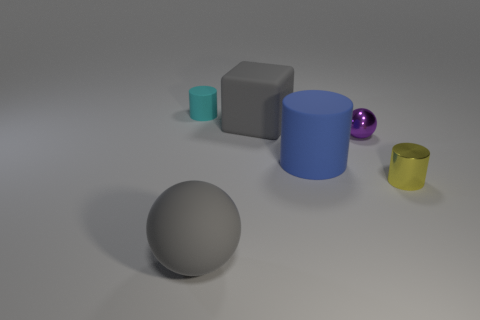What color is the ball that is the same material as the yellow object?
Make the answer very short. Purple. How many metal things are either tiny yellow things or large cubes?
Provide a short and direct response. 1. Is the material of the tiny purple object the same as the large sphere?
Keep it short and to the point. No. There is a rubber thing in front of the yellow cylinder; what shape is it?
Offer a very short reply. Sphere. Are there any matte cylinders that are on the right side of the ball that is in front of the yellow cylinder?
Keep it short and to the point. Yes. Are there any purple shiny spheres that have the same size as the yellow object?
Ensure brevity in your answer.  Yes. There is a cylinder that is on the left side of the large matte block; is its color the same as the big sphere?
Make the answer very short. No. The blue cylinder is what size?
Give a very brief answer. Large. What size is the gray object behind the gray ball in front of the large rubber cylinder?
Your answer should be compact. Large. How many things have the same color as the large matte block?
Your answer should be compact. 1. 